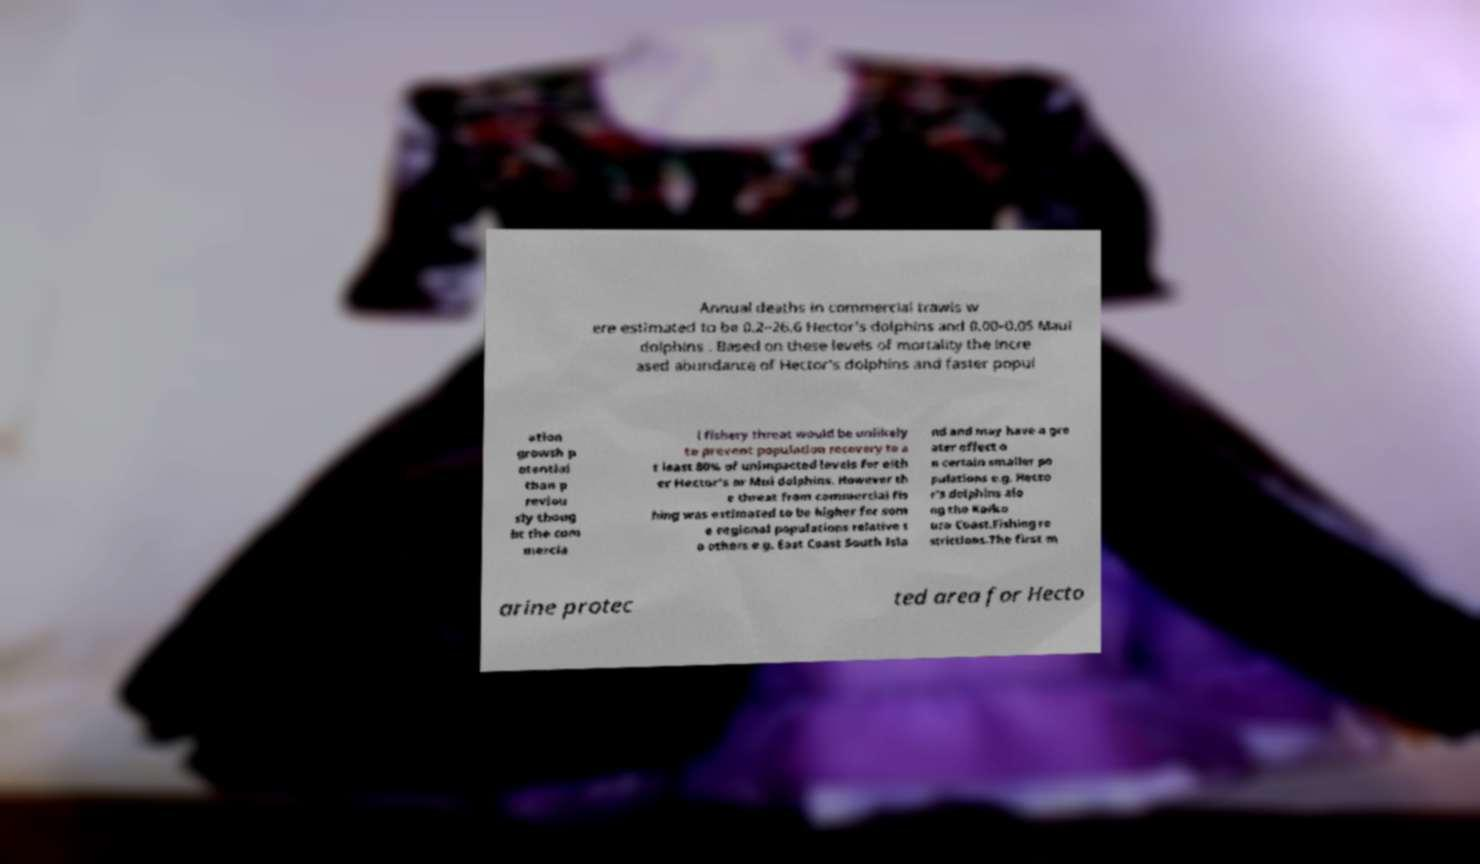Please read and relay the text visible in this image. What does it say? Annual deaths in commercial trawls w ere estimated to be 0.2–26.6 Hector's dolphins and 0.00–0.05 Maui dolphins . Based on these levels of mortality the incre ased abundance of Hector's dolphins and faster popul ation growth p otential than p reviou sly thoug ht the com mercia l fishery threat would be unlikely to prevent population recovery to a t least 80% of unimpacted levels for eith er Hector's or Mui dolphins. However th e threat from commercial fis hing was estimated to be higher for som e regional populations relative t o others e.g. East Coast South Isla nd and may have a gre ater effect o n certain smaller po pulations e.g. Hecto r's dolphins alo ng the Kaiko ura Coast.Fishing re strictions.The first m arine protec ted area for Hecto 